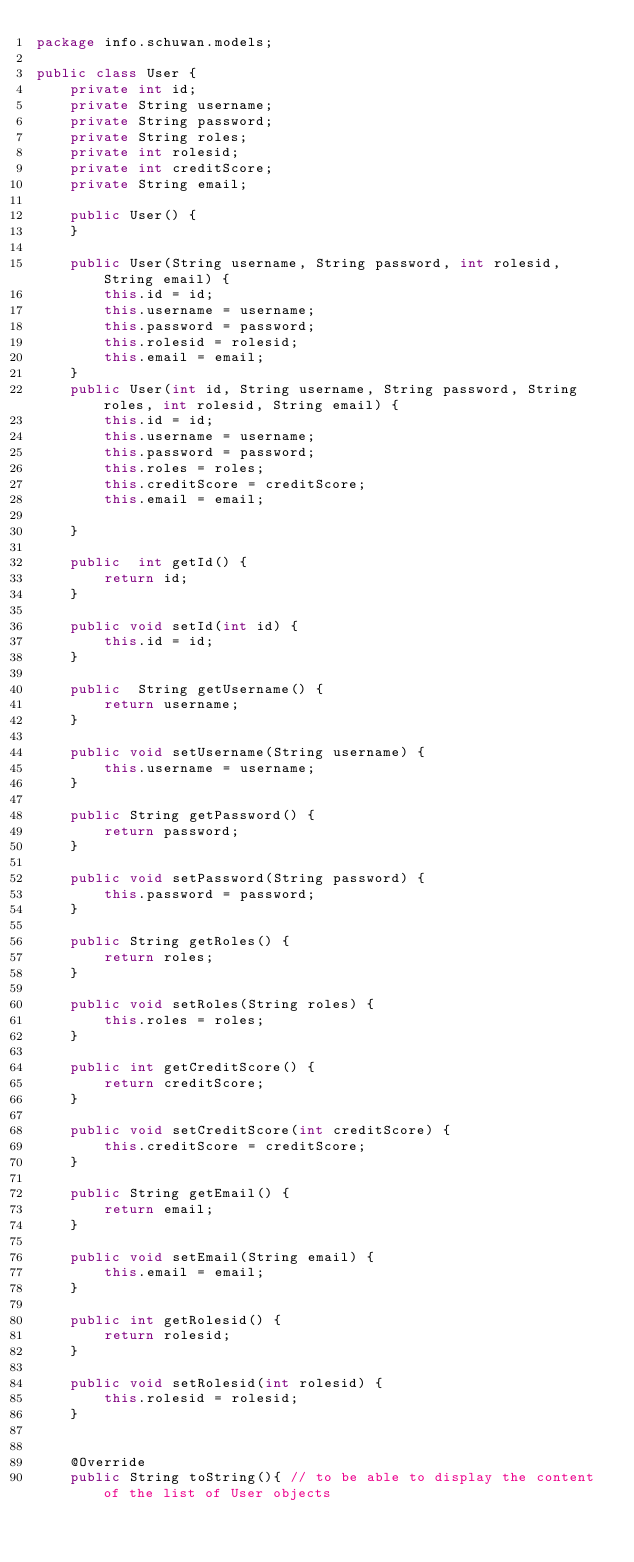Convert code to text. <code><loc_0><loc_0><loc_500><loc_500><_Java_>package info.schuwan.models;

public class User {
    private int id;
    private String username;
    private String password;
    private String roles;
    private int rolesid;
    private int creditScore;
    private String email;

    public User() {
    }

    public User(String username, String password, int rolesid, String email) {
        this.id = id;
        this.username = username;
        this.password = password;
        this.rolesid = rolesid;
        this.email = email;
    }
    public User(int id, String username, String password, String roles, int rolesid, String email) {
        this.id = id;
        this.username = username;
        this.password = password;
        this.roles = roles;
        this.creditScore = creditScore;
        this.email = email;

    }

    public  int getId() {
        return id;
    }

    public void setId(int id) {
        this.id = id;
    }

    public  String getUsername() {
        return username;
    }

    public void setUsername(String username) {
        this.username = username;
    }

    public String getPassword() {
        return password;
    }

    public void setPassword(String password) {
        this.password = password;
    }

    public String getRoles() {
        return roles;
    }

    public void setRoles(String roles) {
        this.roles = roles;
    }

    public int getCreditScore() {
        return creditScore;
    }

    public void setCreditScore(int creditScore) {
        this.creditScore = creditScore;
    }

    public String getEmail() {
        return email;
    }

    public void setEmail(String email) {
        this.email = email;
    }

    public int getRolesid() {
        return rolesid;
    }

    public void setRolesid(int rolesid) {
        this.rolesid = rolesid;
    }


    @Override
    public String toString(){ // to be able to display the content of the list of User objects</code> 